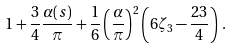<formula> <loc_0><loc_0><loc_500><loc_500>1 + \frac { 3 } { 4 } \frac { \alpha ( s ) } { \pi } + \frac { 1 } { 6 } \left ( \frac { \alpha } { \pi } \right ) ^ { 2 } \left ( 6 \zeta _ { 3 } - \frac { 2 3 } { 4 } \right ) \, .</formula> 